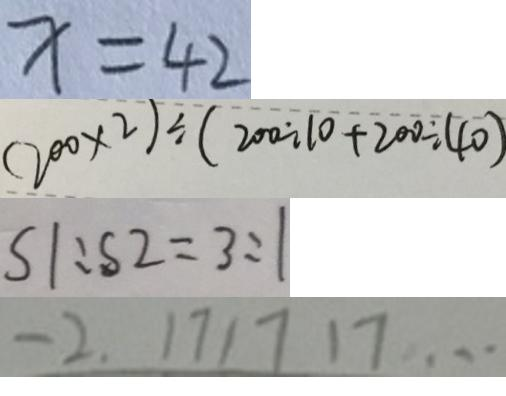Convert formula to latex. <formula><loc_0><loc_0><loc_500><loc_500>x = 4 2 
 ( 2 0 0 \times 2 ) \div ( 2 0 0 \div 1 0 + 2 0 0 \div 4 0 ) 
 S 1 : S 2 = 3 : 1 
 - 2 . 1 7 1 7 1 7 \cdots</formula> 